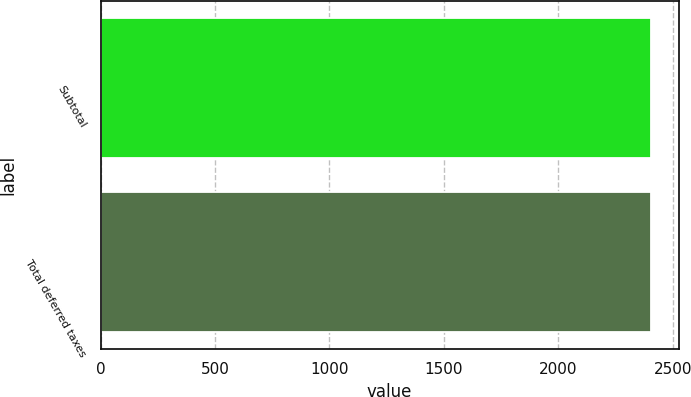Convert chart to OTSL. <chart><loc_0><loc_0><loc_500><loc_500><bar_chart><fcel>Subtotal<fcel>Total deferred taxes<nl><fcel>2406<fcel>2406.1<nl></chart> 